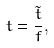<formula> <loc_0><loc_0><loc_500><loc_500>t = \frac { \tilde { t } } { f } ,</formula> 